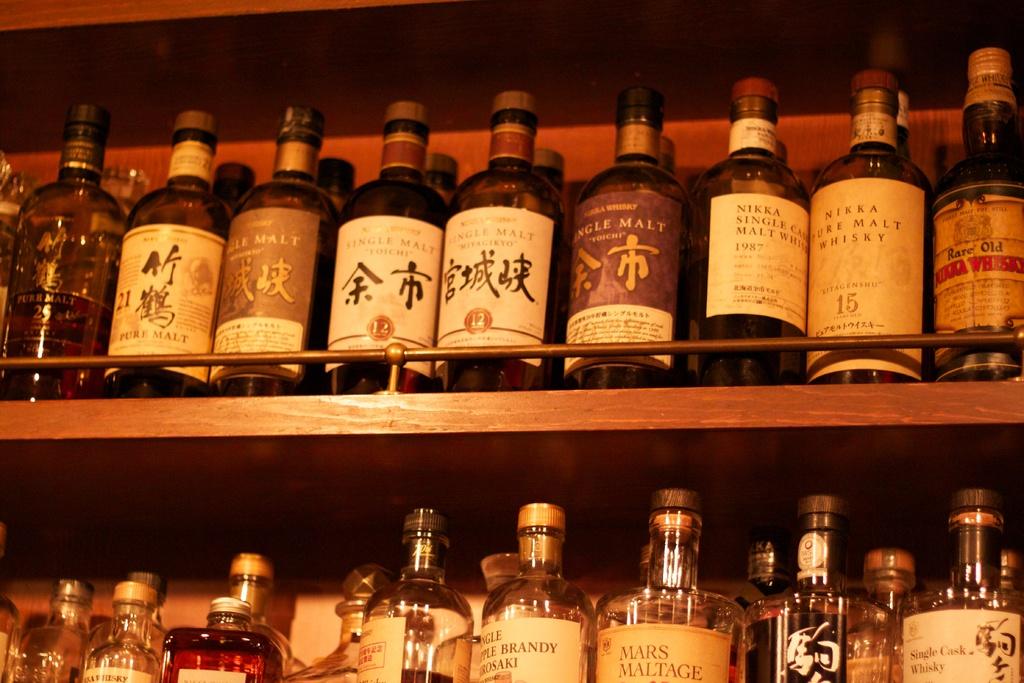What planet name is on the bottle of maltage in the second row?
Your answer should be compact. Mars. What number is on the bottle of nikka pure malt whisky?
Provide a short and direct response. 15. 